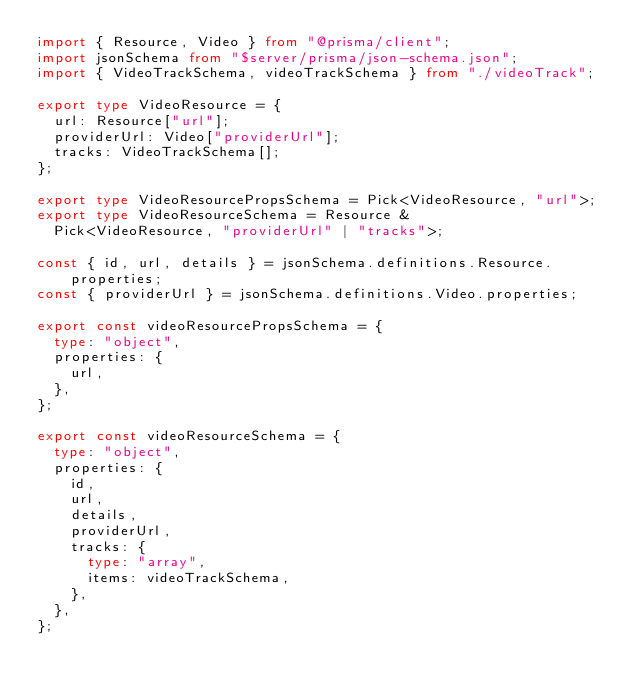Convert code to text. <code><loc_0><loc_0><loc_500><loc_500><_TypeScript_>import { Resource, Video } from "@prisma/client";
import jsonSchema from "$server/prisma/json-schema.json";
import { VideoTrackSchema, videoTrackSchema } from "./videoTrack";

export type VideoResource = {
  url: Resource["url"];
  providerUrl: Video["providerUrl"];
  tracks: VideoTrackSchema[];
};

export type VideoResourcePropsSchema = Pick<VideoResource, "url">;
export type VideoResourceSchema = Resource &
  Pick<VideoResource, "providerUrl" | "tracks">;

const { id, url, details } = jsonSchema.definitions.Resource.properties;
const { providerUrl } = jsonSchema.definitions.Video.properties;

export const videoResourcePropsSchema = {
  type: "object",
  properties: {
    url,
  },
};

export const videoResourceSchema = {
  type: "object",
  properties: {
    id,
    url,
    details,
    providerUrl,
    tracks: {
      type: "array",
      items: videoTrackSchema,
    },
  },
};
</code> 